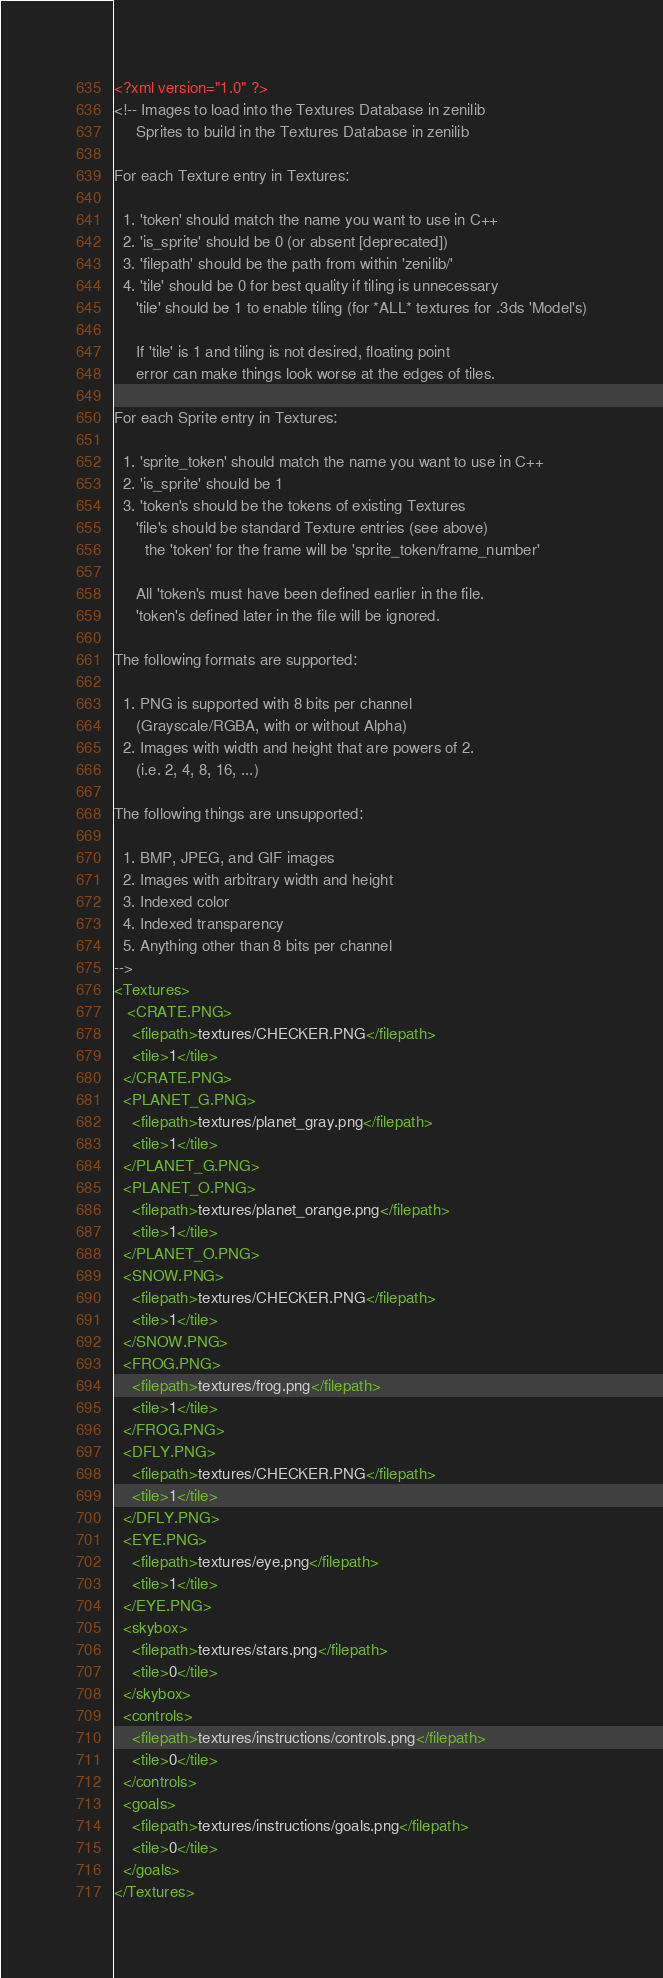<code> <loc_0><loc_0><loc_500><loc_500><_XML_><?xml version="1.0" ?>
<!-- Images to load into the Textures Database in zenilib
     Sprites to build in the Textures Database in zenilib

For each Texture entry in Textures:

  1. 'token' should match the name you want to use in C++
  2. 'is_sprite' should be 0 (or absent [deprecated])
  3. 'filepath' should be the path from within 'zenilib/'
  4. 'tile' should be 0 for best quality if tiling is unnecessary
     'tile' should be 1 to enable tiling (for *ALL* textures for .3ds 'Model's)
       
     If 'tile' is 1 and tiling is not desired, floating point
     error can make things look worse at the edges of tiles.

For each Sprite entry in Textures:

  1. 'sprite_token' should match the name you want to use in C++
  2. 'is_sprite' should be 1
  3. 'token's should be the tokens of existing Textures
     'file's should be standard Texture entries (see above)
       the 'token' for the frame will be 'sprite_token/frame_number'
     
     All 'token's must have been defined earlier in the file.
     'token's defined later in the file will be ignored.

The following formats are supported:

  1. PNG is supported with 8 bits per channel
     (Grayscale/RGBA, with or without Alpha)
  2. Images with width and height that are powers of 2.
     (i.e. 2, 4, 8, 16, ...)

The following things are unsupported:

  1. BMP, JPEG, and GIF images
  2. Images with arbitrary width and height
  3. Indexed color
  4. Indexed transparency
  5. Anything other than 8 bits per channel
-->
<Textures>
   <CRATE.PNG>
    <filepath>textures/CHECKER.PNG</filepath>
    <tile>1</tile>
  </CRATE.PNG>
  <PLANET_G.PNG>
    <filepath>textures/planet_gray.png</filepath>
    <tile>1</tile>
  </PLANET_G.PNG>
  <PLANET_O.PNG>
	<filepath>textures/planet_orange.png</filepath>
    <tile>1</tile>
  </PLANET_O.PNG>
  <SNOW.PNG>
    <filepath>textures/CHECKER.PNG</filepath>
    <tile>1</tile>
  </SNOW.PNG>
  <FROG.PNG>
    <filepath>textures/frog.png</filepath>
    <tile>1</tile>
  </FROG.PNG>
  <DFLY.PNG>
    <filepath>textures/CHECKER.PNG</filepath>
    <tile>1</tile>
  </DFLY.PNG>
  <EYE.PNG>
	<filepath>textures/eye.png</filepath>
	<tile>1</tile>
  </EYE.PNG>
  <skybox>
	<filepath>textures/stars.png</filepath>
	<tile>0</tile>
  </skybox>
  <controls>
	<filepath>textures/instructions/controls.png</filepath>
	<tile>0</tile>
  </controls>
  <goals>
	<filepath>textures/instructions/goals.png</filepath>
	<tile>0</tile>
  </goals>
</Textures>
</code> 